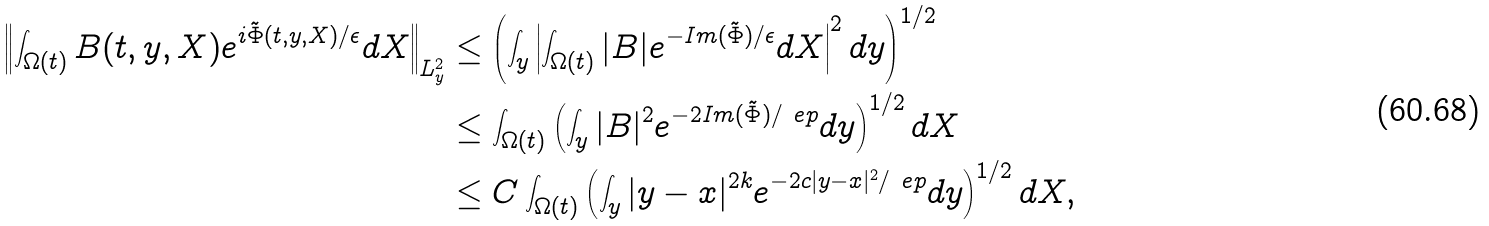<formula> <loc_0><loc_0><loc_500><loc_500>\left \| \int _ { \Omega ( t ) } B ( t , y , X ) e ^ { i \tilde { \Phi } ( t , y , X ) / \epsilon } d X \right \| _ { L ^ { 2 } _ { y } } & \leq \left ( \int _ { y } \left | \int _ { \Omega ( t ) } | B | e ^ { - I m ( \tilde { \Phi } ) / \epsilon } d X \right | ^ { 2 } d y \right ) ^ { 1 / 2 } \\ & \leq \int _ { \Omega ( t ) } \left ( \int _ { y } | B | ^ { 2 } e ^ { - 2 I m ( \tilde { \Phi } ) / \ e p } d y \right ) ^ { 1 / 2 } d X \\ & \leq C \int _ { \Omega ( t ) } \left ( \int _ { y } | y - x | ^ { 2 k } e ^ { - 2 c | y - x | ^ { 2 } / \ e p } d y \right ) ^ { 1 / 2 } d X ,</formula> 